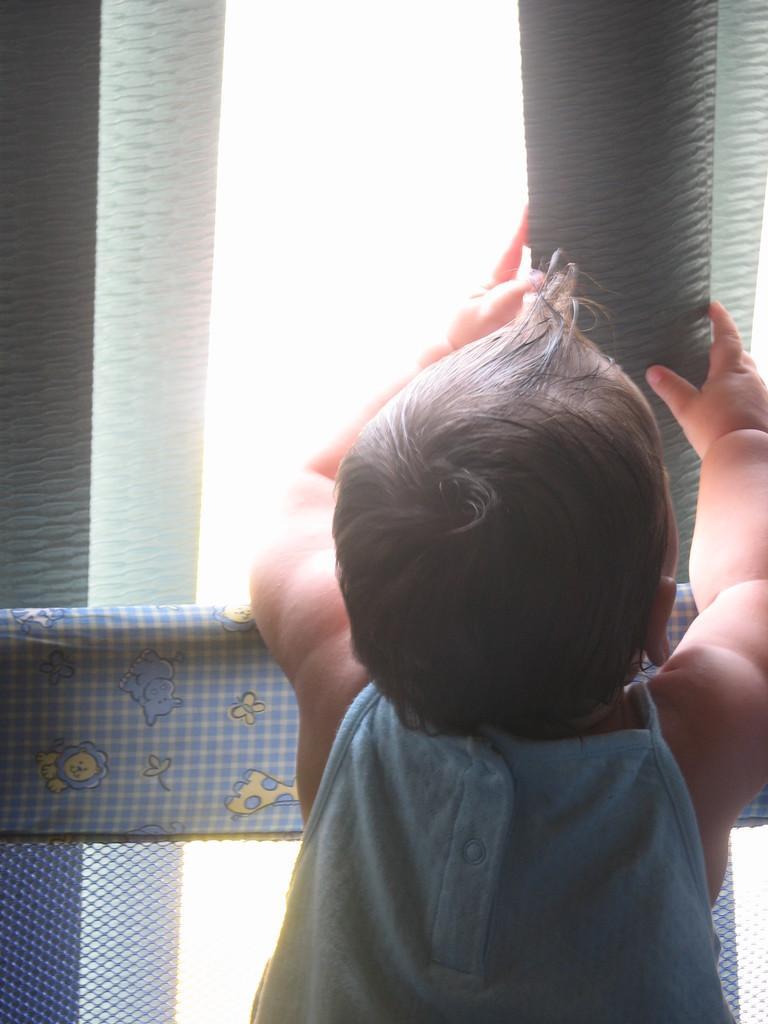In one or two sentences, can you explain what this image depicts? On the right side of the image we can see a kid is standing and holding a plastic strip curtain. At the bottom of the image we can see the mesh, cloth. At the top of the image we can see the plastic strip curtain. 